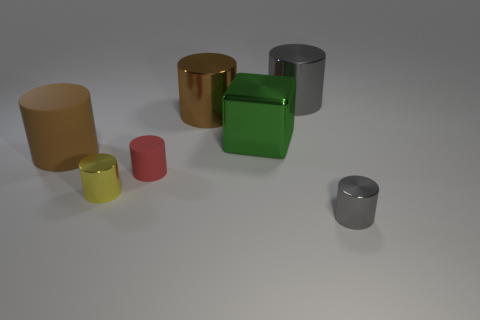Subtract all large brown rubber cylinders. How many cylinders are left? 5 Subtract all yellow cubes. How many brown cylinders are left? 2 Add 3 large red metallic cylinders. How many objects exist? 10 Subtract all brown cylinders. How many cylinders are left? 4 Subtract all cubes. How many objects are left? 6 Subtract 2 brown cylinders. How many objects are left? 5 Subtract 5 cylinders. How many cylinders are left? 1 Subtract all brown cubes. Subtract all purple spheres. How many cubes are left? 1 Subtract all big matte cylinders. Subtract all small red matte cylinders. How many objects are left? 5 Add 5 small metal cylinders. How many small metal cylinders are left? 7 